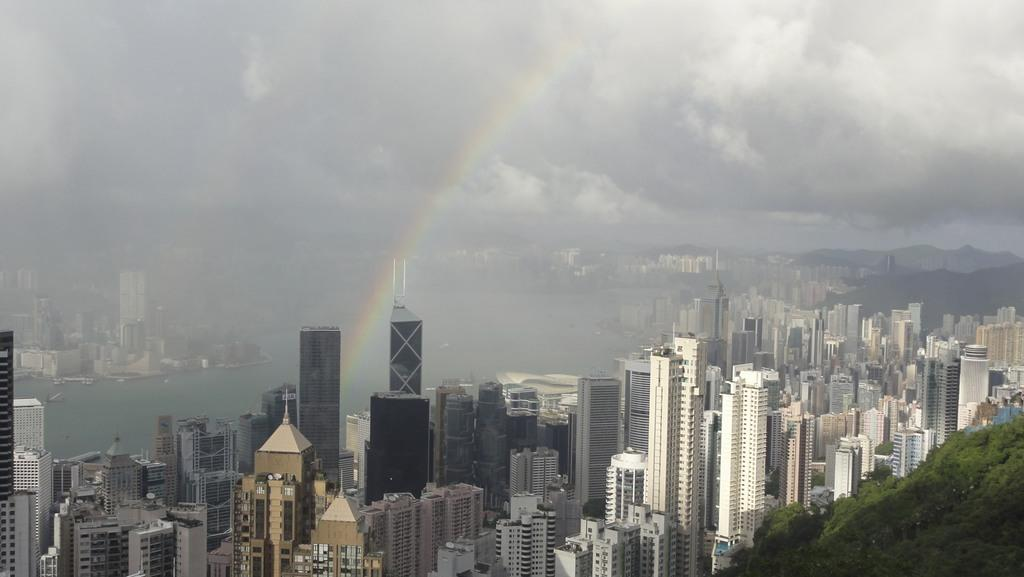What type of structures can be seen in the image? There are buildings in the image. What natural elements are present in the image? There are trees and water visible in the image. What additional feature can be observed in the sky? A rainbow is present in the image. What is the condition of the sky in the image? The sky is cloudy in the image. Where is the aunt resting in the image? There is no aunt present in the image. What point is the rainbow making in the image? The rainbow is not making a point in the image; it is a natural phenomenon that occurs due to the refraction of light. 